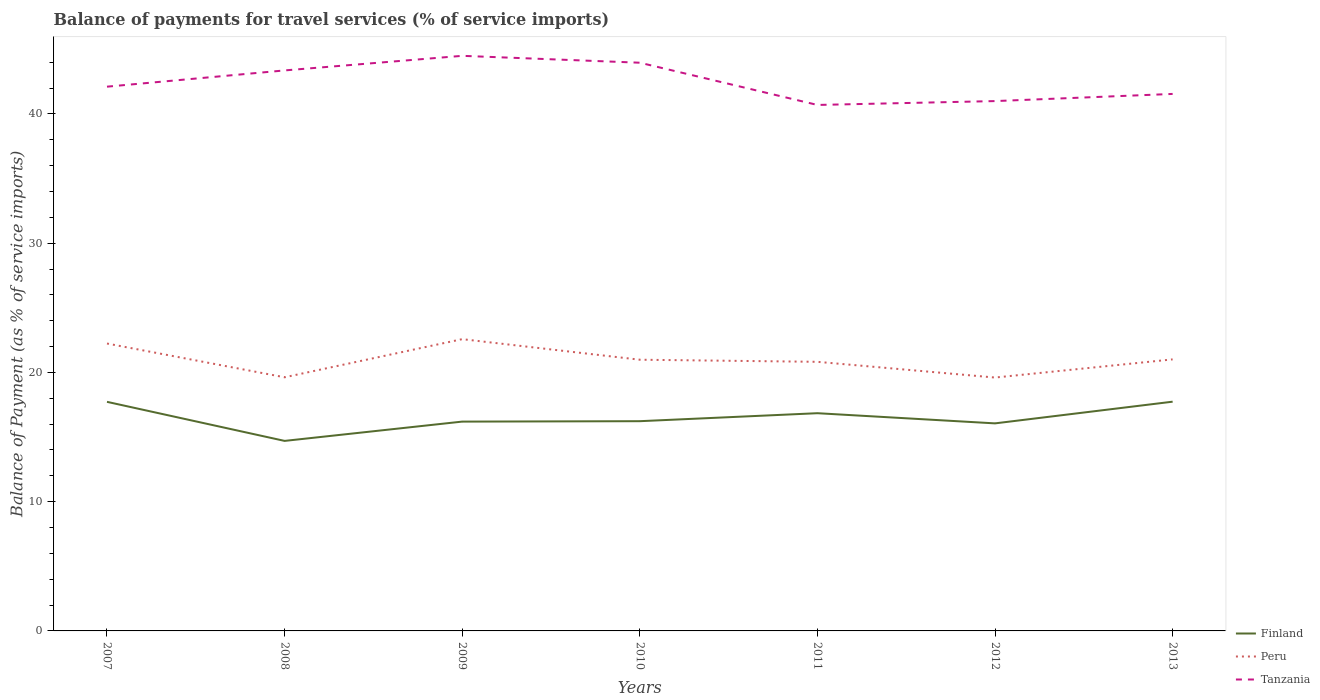Does the line corresponding to Peru intersect with the line corresponding to Tanzania?
Ensure brevity in your answer.  No. Across all years, what is the maximum balance of payments for travel services in Finland?
Ensure brevity in your answer.  14.7. In which year was the balance of payments for travel services in Tanzania maximum?
Provide a short and direct response. 2011. What is the total balance of payments for travel services in Tanzania in the graph?
Your answer should be very brief. 3.27. What is the difference between the highest and the second highest balance of payments for travel services in Tanzania?
Make the answer very short. 3.8. Is the balance of payments for travel services in Tanzania strictly greater than the balance of payments for travel services in Peru over the years?
Offer a very short reply. No. How many years are there in the graph?
Make the answer very short. 7. What is the difference between two consecutive major ticks on the Y-axis?
Ensure brevity in your answer.  10. Are the values on the major ticks of Y-axis written in scientific E-notation?
Offer a terse response. No. Where does the legend appear in the graph?
Offer a very short reply. Bottom right. How many legend labels are there?
Offer a terse response. 3. What is the title of the graph?
Give a very brief answer. Balance of payments for travel services (% of service imports). Does "New Zealand" appear as one of the legend labels in the graph?
Keep it short and to the point. No. What is the label or title of the Y-axis?
Your response must be concise. Balance of Payment (as % of service imports). What is the Balance of Payment (as % of service imports) of Finland in 2007?
Offer a very short reply. 17.73. What is the Balance of Payment (as % of service imports) of Peru in 2007?
Give a very brief answer. 22.24. What is the Balance of Payment (as % of service imports) in Tanzania in 2007?
Provide a short and direct response. 42.11. What is the Balance of Payment (as % of service imports) in Finland in 2008?
Provide a succinct answer. 14.7. What is the Balance of Payment (as % of service imports) of Peru in 2008?
Provide a short and direct response. 19.62. What is the Balance of Payment (as % of service imports) of Tanzania in 2008?
Your answer should be compact. 43.37. What is the Balance of Payment (as % of service imports) of Finland in 2009?
Provide a short and direct response. 16.2. What is the Balance of Payment (as % of service imports) in Peru in 2009?
Offer a very short reply. 22.58. What is the Balance of Payment (as % of service imports) of Tanzania in 2009?
Make the answer very short. 44.5. What is the Balance of Payment (as % of service imports) in Finland in 2010?
Your response must be concise. 16.23. What is the Balance of Payment (as % of service imports) in Peru in 2010?
Ensure brevity in your answer.  20.98. What is the Balance of Payment (as % of service imports) in Tanzania in 2010?
Your answer should be compact. 43.96. What is the Balance of Payment (as % of service imports) of Finland in 2011?
Provide a succinct answer. 16.85. What is the Balance of Payment (as % of service imports) of Peru in 2011?
Keep it short and to the point. 20.82. What is the Balance of Payment (as % of service imports) in Tanzania in 2011?
Give a very brief answer. 40.7. What is the Balance of Payment (as % of service imports) in Finland in 2012?
Your answer should be compact. 16.06. What is the Balance of Payment (as % of service imports) of Peru in 2012?
Offer a terse response. 19.6. What is the Balance of Payment (as % of service imports) of Tanzania in 2012?
Offer a very short reply. 40.99. What is the Balance of Payment (as % of service imports) of Finland in 2013?
Make the answer very short. 17.74. What is the Balance of Payment (as % of service imports) in Peru in 2013?
Your answer should be very brief. 21.01. What is the Balance of Payment (as % of service imports) of Tanzania in 2013?
Provide a short and direct response. 41.55. Across all years, what is the maximum Balance of Payment (as % of service imports) of Finland?
Make the answer very short. 17.74. Across all years, what is the maximum Balance of Payment (as % of service imports) of Peru?
Provide a succinct answer. 22.58. Across all years, what is the maximum Balance of Payment (as % of service imports) in Tanzania?
Your response must be concise. 44.5. Across all years, what is the minimum Balance of Payment (as % of service imports) in Finland?
Give a very brief answer. 14.7. Across all years, what is the minimum Balance of Payment (as % of service imports) in Peru?
Provide a short and direct response. 19.6. Across all years, what is the minimum Balance of Payment (as % of service imports) in Tanzania?
Provide a succinct answer. 40.7. What is the total Balance of Payment (as % of service imports) of Finland in the graph?
Provide a short and direct response. 115.49. What is the total Balance of Payment (as % of service imports) of Peru in the graph?
Keep it short and to the point. 146.85. What is the total Balance of Payment (as % of service imports) of Tanzania in the graph?
Keep it short and to the point. 297.18. What is the difference between the Balance of Payment (as % of service imports) in Finland in 2007 and that in 2008?
Your answer should be compact. 3.02. What is the difference between the Balance of Payment (as % of service imports) of Peru in 2007 and that in 2008?
Your response must be concise. 2.61. What is the difference between the Balance of Payment (as % of service imports) in Tanzania in 2007 and that in 2008?
Offer a very short reply. -1.26. What is the difference between the Balance of Payment (as % of service imports) in Finland in 2007 and that in 2009?
Make the answer very short. 1.53. What is the difference between the Balance of Payment (as % of service imports) in Peru in 2007 and that in 2009?
Give a very brief answer. -0.34. What is the difference between the Balance of Payment (as % of service imports) of Tanzania in 2007 and that in 2009?
Provide a succinct answer. -2.39. What is the difference between the Balance of Payment (as % of service imports) in Finland in 2007 and that in 2010?
Ensure brevity in your answer.  1.5. What is the difference between the Balance of Payment (as % of service imports) of Peru in 2007 and that in 2010?
Offer a very short reply. 1.25. What is the difference between the Balance of Payment (as % of service imports) of Tanzania in 2007 and that in 2010?
Offer a very short reply. -1.85. What is the difference between the Balance of Payment (as % of service imports) of Peru in 2007 and that in 2011?
Provide a short and direct response. 1.42. What is the difference between the Balance of Payment (as % of service imports) in Tanzania in 2007 and that in 2011?
Your answer should be very brief. 1.41. What is the difference between the Balance of Payment (as % of service imports) in Finland in 2007 and that in 2012?
Provide a succinct answer. 1.67. What is the difference between the Balance of Payment (as % of service imports) in Peru in 2007 and that in 2012?
Your answer should be very brief. 2.63. What is the difference between the Balance of Payment (as % of service imports) in Tanzania in 2007 and that in 2012?
Your response must be concise. 1.11. What is the difference between the Balance of Payment (as % of service imports) in Finland in 2007 and that in 2013?
Make the answer very short. -0.01. What is the difference between the Balance of Payment (as % of service imports) of Peru in 2007 and that in 2013?
Provide a succinct answer. 1.23. What is the difference between the Balance of Payment (as % of service imports) of Tanzania in 2007 and that in 2013?
Provide a succinct answer. 0.56. What is the difference between the Balance of Payment (as % of service imports) of Finland in 2008 and that in 2009?
Your answer should be very brief. -1.49. What is the difference between the Balance of Payment (as % of service imports) in Peru in 2008 and that in 2009?
Provide a succinct answer. -2.95. What is the difference between the Balance of Payment (as % of service imports) in Tanzania in 2008 and that in 2009?
Provide a short and direct response. -1.13. What is the difference between the Balance of Payment (as % of service imports) in Finland in 2008 and that in 2010?
Provide a short and direct response. -1.53. What is the difference between the Balance of Payment (as % of service imports) in Peru in 2008 and that in 2010?
Provide a succinct answer. -1.36. What is the difference between the Balance of Payment (as % of service imports) in Tanzania in 2008 and that in 2010?
Offer a terse response. -0.6. What is the difference between the Balance of Payment (as % of service imports) of Finland in 2008 and that in 2011?
Your answer should be compact. -2.14. What is the difference between the Balance of Payment (as % of service imports) of Peru in 2008 and that in 2011?
Provide a short and direct response. -1.2. What is the difference between the Balance of Payment (as % of service imports) of Tanzania in 2008 and that in 2011?
Make the answer very short. 2.67. What is the difference between the Balance of Payment (as % of service imports) of Finland in 2008 and that in 2012?
Offer a terse response. -1.36. What is the difference between the Balance of Payment (as % of service imports) in Peru in 2008 and that in 2012?
Give a very brief answer. 0.02. What is the difference between the Balance of Payment (as % of service imports) of Tanzania in 2008 and that in 2012?
Provide a succinct answer. 2.37. What is the difference between the Balance of Payment (as % of service imports) in Finland in 2008 and that in 2013?
Provide a succinct answer. -3.03. What is the difference between the Balance of Payment (as % of service imports) in Peru in 2008 and that in 2013?
Ensure brevity in your answer.  -1.39. What is the difference between the Balance of Payment (as % of service imports) in Tanzania in 2008 and that in 2013?
Your response must be concise. 1.82. What is the difference between the Balance of Payment (as % of service imports) in Finland in 2009 and that in 2010?
Offer a terse response. -0.03. What is the difference between the Balance of Payment (as % of service imports) of Peru in 2009 and that in 2010?
Ensure brevity in your answer.  1.59. What is the difference between the Balance of Payment (as % of service imports) of Tanzania in 2009 and that in 2010?
Make the answer very short. 0.53. What is the difference between the Balance of Payment (as % of service imports) in Finland in 2009 and that in 2011?
Offer a very short reply. -0.65. What is the difference between the Balance of Payment (as % of service imports) of Peru in 2009 and that in 2011?
Keep it short and to the point. 1.75. What is the difference between the Balance of Payment (as % of service imports) of Tanzania in 2009 and that in 2011?
Give a very brief answer. 3.8. What is the difference between the Balance of Payment (as % of service imports) in Finland in 2009 and that in 2012?
Your answer should be compact. 0.14. What is the difference between the Balance of Payment (as % of service imports) in Peru in 2009 and that in 2012?
Your answer should be compact. 2.97. What is the difference between the Balance of Payment (as % of service imports) in Tanzania in 2009 and that in 2012?
Offer a very short reply. 3.5. What is the difference between the Balance of Payment (as % of service imports) of Finland in 2009 and that in 2013?
Ensure brevity in your answer.  -1.54. What is the difference between the Balance of Payment (as % of service imports) of Peru in 2009 and that in 2013?
Provide a succinct answer. 1.57. What is the difference between the Balance of Payment (as % of service imports) of Tanzania in 2009 and that in 2013?
Ensure brevity in your answer.  2.95. What is the difference between the Balance of Payment (as % of service imports) of Finland in 2010 and that in 2011?
Make the answer very short. -0.62. What is the difference between the Balance of Payment (as % of service imports) in Peru in 2010 and that in 2011?
Make the answer very short. 0.16. What is the difference between the Balance of Payment (as % of service imports) of Tanzania in 2010 and that in 2011?
Your answer should be very brief. 3.27. What is the difference between the Balance of Payment (as % of service imports) in Finland in 2010 and that in 2012?
Ensure brevity in your answer.  0.17. What is the difference between the Balance of Payment (as % of service imports) of Peru in 2010 and that in 2012?
Offer a terse response. 1.38. What is the difference between the Balance of Payment (as % of service imports) in Tanzania in 2010 and that in 2012?
Ensure brevity in your answer.  2.97. What is the difference between the Balance of Payment (as % of service imports) of Finland in 2010 and that in 2013?
Your answer should be compact. -1.51. What is the difference between the Balance of Payment (as % of service imports) of Peru in 2010 and that in 2013?
Your answer should be very brief. -0.03. What is the difference between the Balance of Payment (as % of service imports) of Tanzania in 2010 and that in 2013?
Keep it short and to the point. 2.42. What is the difference between the Balance of Payment (as % of service imports) in Finland in 2011 and that in 2012?
Keep it short and to the point. 0.79. What is the difference between the Balance of Payment (as % of service imports) of Peru in 2011 and that in 2012?
Ensure brevity in your answer.  1.22. What is the difference between the Balance of Payment (as % of service imports) of Tanzania in 2011 and that in 2012?
Your answer should be compact. -0.3. What is the difference between the Balance of Payment (as % of service imports) of Finland in 2011 and that in 2013?
Your answer should be very brief. -0.89. What is the difference between the Balance of Payment (as % of service imports) in Peru in 2011 and that in 2013?
Give a very brief answer. -0.19. What is the difference between the Balance of Payment (as % of service imports) in Tanzania in 2011 and that in 2013?
Keep it short and to the point. -0.85. What is the difference between the Balance of Payment (as % of service imports) of Finland in 2012 and that in 2013?
Make the answer very short. -1.68. What is the difference between the Balance of Payment (as % of service imports) of Peru in 2012 and that in 2013?
Give a very brief answer. -1.41. What is the difference between the Balance of Payment (as % of service imports) in Tanzania in 2012 and that in 2013?
Provide a succinct answer. -0.55. What is the difference between the Balance of Payment (as % of service imports) in Finland in 2007 and the Balance of Payment (as % of service imports) in Peru in 2008?
Offer a very short reply. -1.9. What is the difference between the Balance of Payment (as % of service imports) of Finland in 2007 and the Balance of Payment (as % of service imports) of Tanzania in 2008?
Provide a succinct answer. -25.64. What is the difference between the Balance of Payment (as % of service imports) in Peru in 2007 and the Balance of Payment (as % of service imports) in Tanzania in 2008?
Keep it short and to the point. -21.13. What is the difference between the Balance of Payment (as % of service imports) in Finland in 2007 and the Balance of Payment (as % of service imports) in Peru in 2009?
Offer a very short reply. -4.85. What is the difference between the Balance of Payment (as % of service imports) of Finland in 2007 and the Balance of Payment (as % of service imports) of Tanzania in 2009?
Ensure brevity in your answer.  -26.77. What is the difference between the Balance of Payment (as % of service imports) in Peru in 2007 and the Balance of Payment (as % of service imports) in Tanzania in 2009?
Make the answer very short. -22.26. What is the difference between the Balance of Payment (as % of service imports) in Finland in 2007 and the Balance of Payment (as % of service imports) in Peru in 2010?
Provide a succinct answer. -3.26. What is the difference between the Balance of Payment (as % of service imports) of Finland in 2007 and the Balance of Payment (as % of service imports) of Tanzania in 2010?
Make the answer very short. -26.24. What is the difference between the Balance of Payment (as % of service imports) of Peru in 2007 and the Balance of Payment (as % of service imports) of Tanzania in 2010?
Provide a succinct answer. -21.73. What is the difference between the Balance of Payment (as % of service imports) in Finland in 2007 and the Balance of Payment (as % of service imports) in Peru in 2011?
Make the answer very short. -3.1. What is the difference between the Balance of Payment (as % of service imports) in Finland in 2007 and the Balance of Payment (as % of service imports) in Tanzania in 2011?
Offer a very short reply. -22.97. What is the difference between the Balance of Payment (as % of service imports) of Peru in 2007 and the Balance of Payment (as % of service imports) of Tanzania in 2011?
Your answer should be very brief. -18.46. What is the difference between the Balance of Payment (as % of service imports) of Finland in 2007 and the Balance of Payment (as % of service imports) of Peru in 2012?
Ensure brevity in your answer.  -1.88. What is the difference between the Balance of Payment (as % of service imports) in Finland in 2007 and the Balance of Payment (as % of service imports) in Tanzania in 2012?
Give a very brief answer. -23.27. What is the difference between the Balance of Payment (as % of service imports) of Peru in 2007 and the Balance of Payment (as % of service imports) of Tanzania in 2012?
Ensure brevity in your answer.  -18.76. What is the difference between the Balance of Payment (as % of service imports) in Finland in 2007 and the Balance of Payment (as % of service imports) in Peru in 2013?
Provide a short and direct response. -3.28. What is the difference between the Balance of Payment (as % of service imports) of Finland in 2007 and the Balance of Payment (as % of service imports) of Tanzania in 2013?
Your answer should be very brief. -23.82. What is the difference between the Balance of Payment (as % of service imports) in Peru in 2007 and the Balance of Payment (as % of service imports) in Tanzania in 2013?
Provide a short and direct response. -19.31. What is the difference between the Balance of Payment (as % of service imports) in Finland in 2008 and the Balance of Payment (as % of service imports) in Peru in 2009?
Offer a very short reply. -7.87. What is the difference between the Balance of Payment (as % of service imports) in Finland in 2008 and the Balance of Payment (as % of service imports) in Tanzania in 2009?
Offer a very short reply. -29.79. What is the difference between the Balance of Payment (as % of service imports) of Peru in 2008 and the Balance of Payment (as % of service imports) of Tanzania in 2009?
Keep it short and to the point. -24.87. What is the difference between the Balance of Payment (as % of service imports) of Finland in 2008 and the Balance of Payment (as % of service imports) of Peru in 2010?
Keep it short and to the point. -6.28. What is the difference between the Balance of Payment (as % of service imports) of Finland in 2008 and the Balance of Payment (as % of service imports) of Tanzania in 2010?
Your answer should be very brief. -29.26. What is the difference between the Balance of Payment (as % of service imports) in Peru in 2008 and the Balance of Payment (as % of service imports) in Tanzania in 2010?
Your answer should be compact. -24.34. What is the difference between the Balance of Payment (as % of service imports) of Finland in 2008 and the Balance of Payment (as % of service imports) of Peru in 2011?
Provide a short and direct response. -6.12. What is the difference between the Balance of Payment (as % of service imports) in Finland in 2008 and the Balance of Payment (as % of service imports) in Tanzania in 2011?
Keep it short and to the point. -25.99. What is the difference between the Balance of Payment (as % of service imports) of Peru in 2008 and the Balance of Payment (as % of service imports) of Tanzania in 2011?
Offer a very short reply. -21.07. What is the difference between the Balance of Payment (as % of service imports) in Finland in 2008 and the Balance of Payment (as % of service imports) in Peru in 2012?
Make the answer very short. -4.9. What is the difference between the Balance of Payment (as % of service imports) of Finland in 2008 and the Balance of Payment (as % of service imports) of Tanzania in 2012?
Your response must be concise. -26.29. What is the difference between the Balance of Payment (as % of service imports) in Peru in 2008 and the Balance of Payment (as % of service imports) in Tanzania in 2012?
Keep it short and to the point. -21.37. What is the difference between the Balance of Payment (as % of service imports) in Finland in 2008 and the Balance of Payment (as % of service imports) in Peru in 2013?
Offer a very short reply. -6.31. What is the difference between the Balance of Payment (as % of service imports) of Finland in 2008 and the Balance of Payment (as % of service imports) of Tanzania in 2013?
Offer a very short reply. -26.85. What is the difference between the Balance of Payment (as % of service imports) of Peru in 2008 and the Balance of Payment (as % of service imports) of Tanzania in 2013?
Your answer should be very brief. -21.92. What is the difference between the Balance of Payment (as % of service imports) of Finland in 2009 and the Balance of Payment (as % of service imports) of Peru in 2010?
Make the answer very short. -4.79. What is the difference between the Balance of Payment (as % of service imports) of Finland in 2009 and the Balance of Payment (as % of service imports) of Tanzania in 2010?
Ensure brevity in your answer.  -27.77. What is the difference between the Balance of Payment (as % of service imports) of Peru in 2009 and the Balance of Payment (as % of service imports) of Tanzania in 2010?
Your response must be concise. -21.39. What is the difference between the Balance of Payment (as % of service imports) in Finland in 2009 and the Balance of Payment (as % of service imports) in Peru in 2011?
Ensure brevity in your answer.  -4.63. What is the difference between the Balance of Payment (as % of service imports) of Finland in 2009 and the Balance of Payment (as % of service imports) of Tanzania in 2011?
Your answer should be compact. -24.5. What is the difference between the Balance of Payment (as % of service imports) of Peru in 2009 and the Balance of Payment (as % of service imports) of Tanzania in 2011?
Offer a very short reply. -18.12. What is the difference between the Balance of Payment (as % of service imports) in Finland in 2009 and the Balance of Payment (as % of service imports) in Peru in 2012?
Make the answer very short. -3.41. What is the difference between the Balance of Payment (as % of service imports) of Finland in 2009 and the Balance of Payment (as % of service imports) of Tanzania in 2012?
Ensure brevity in your answer.  -24.8. What is the difference between the Balance of Payment (as % of service imports) of Peru in 2009 and the Balance of Payment (as % of service imports) of Tanzania in 2012?
Offer a terse response. -18.42. What is the difference between the Balance of Payment (as % of service imports) of Finland in 2009 and the Balance of Payment (as % of service imports) of Peru in 2013?
Give a very brief answer. -4.81. What is the difference between the Balance of Payment (as % of service imports) of Finland in 2009 and the Balance of Payment (as % of service imports) of Tanzania in 2013?
Provide a succinct answer. -25.35. What is the difference between the Balance of Payment (as % of service imports) in Peru in 2009 and the Balance of Payment (as % of service imports) in Tanzania in 2013?
Give a very brief answer. -18.97. What is the difference between the Balance of Payment (as % of service imports) in Finland in 2010 and the Balance of Payment (as % of service imports) in Peru in 2011?
Your response must be concise. -4.59. What is the difference between the Balance of Payment (as % of service imports) of Finland in 2010 and the Balance of Payment (as % of service imports) of Tanzania in 2011?
Ensure brevity in your answer.  -24.47. What is the difference between the Balance of Payment (as % of service imports) of Peru in 2010 and the Balance of Payment (as % of service imports) of Tanzania in 2011?
Provide a succinct answer. -19.71. What is the difference between the Balance of Payment (as % of service imports) of Finland in 2010 and the Balance of Payment (as % of service imports) of Peru in 2012?
Make the answer very short. -3.38. What is the difference between the Balance of Payment (as % of service imports) in Finland in 2010 and the Balance of Payment (as % of service imports) in Tanzania in 2012?
Give a very brief answer. -24.77. What is the difference between the Balance of Payment (as % of service imports) in Peru in 2010 and the Balance of Payment (as % of service imports) in Tanzania in 2012?
Your answer should be compact. -20.01. What is the difference between the Balance of Payment (as % of service imports) of Finland in 2010 and the Balance of Payment (as % of service imports) of Peru in 2013?
Keep it short and to the point. -4.78. What is the difference between the Balance of Payment (as % of service imports) in Finland in 2010 and the Balance of Payment (as % of service imports) in Tanzania in 2013?
Provide a short and direct response. -25.32. What is the difference between the Balance of Payment (as % of service imports) in Peru in 2010 and the Balance of Payment (as % of service imports) in Tanzania in 2013?
Ensure brevity in your answer.  -20.57. What is the difference between the Balance of Payment (as % of service imports) in Finland in 2011 and the Balance of Payment (as % of service imports) in Peru in 2012?
Give a very brief answer. -2.76. What is the difference between the Balance of Payment (as % of service imports) of Finland in 2011 and the Balance of Payment (as % of service imports) of Tanzania in 2012?
Keep it short and to the point. -24.15. What is the difference between the Balance of Payment (as % of service imports) of Peru in 2011 and the Balance of Payment (as % of service imports) of Tanzania in 2012?
Keep it short and to the point. -20.17. What is the difference between the Balance of Payment (as % of service imports) in Finland in 2011 and the Balance of Payment (as % of service imports) in Peru in 2013?
Make the answer very short. -4.16. What is the difference between the Balance of Payment (as % of service imports) of Finland in 2011 and the Balance of Payment (as % of service imports) of Tanzania in 2013?
Offer a terse response. -24.7. What is the difference between the Balance of Payment (as % of service imports) in Peru in 2011 and the Balance of Payment (as % of service imports) in Tanzania in 2013?
Your answer should be compact. -20.73. What is the difference between the Balance of Payment (as % of service imports) of Finland in 2012 and the Balance of Payment (as % of service imports) of Peru in 2013?
Your answer should be compact. -4.95. What is the difference between the Balance of Payment (as % of service imports) of Finland in 2012 and the Balance of Payment (as % of service imports) of Tanzania in 2013?
Keep it short and to the point. -25.49. What is the difference between the Balance of Payment (as % of service imports) in Peru in 2012 and the Balance of Payment (as % of service imports) in Tanzania in 2013?
Your response must be concise. -21.94. What is the average Balance of Payment (as % of service imports) in Finland per year?
Offer a terse response. 16.5. What is the average Balance of Payment (as % of service imports) in Peru per year?
Your response must be concise. 20.98. What is the average Balance of Payment (as % of service imports) in Tanzania per year?
Ensure brevity in your answer.  42.45. In the year 2007, what is the difference between the Balance of Payment (as % of service imports) of Finland and Balance of Payment (as % of service imports) of Peru?
Your answer should be very brief. -4.51. In the year 2007, what is the difference between the Balance of Payment (as % of service imports) of Finland and Balance of Payment (as % of service imports) of Tanzania?
Offer a terse response. -24.38. In the year 2007, what is the difference between the Balance of Payment (as % of service imports) of Peru and Balance of Payment (as % of service imports) of Tanzania?
Ensure brevity in your answer.  -19.87. In the year 2008, what is the difference between the Balance of Payment (as % of service imports) in Finland and Balance of Payment (as % of service imports) in Peru?
Your answer should be compact. -4.92. In the year 2008, what is the difference between the Balance of Payment (as % of service imports) in Finland and Balance of Payment (as % of service imports) in Tanzania?
Keep it short and to the point. -28.67. In the year 2008, what is the difference between the Balance of Payment (as % of service imports) of Peru and Balance of Payment (as % of service imports) of Tanzania?
Your response must be concise. -23.74. In the year 2009, what is the difference between the Balance of Payment (as % of service imports) of Finland and Balance of Payment (as % of service imports) of Peru?
Offer a terse response. -6.38. In the year 2009, what is the difference between the Balance of Payment (as % of service imports) in Finland and Balance of Payment (as % of service imports) in Tanzania?
Offer a very short reply. -28.3. In the year 2009, what is the difference between the Balance of Payment (as % of service imports) in Peru and Balance of Payment (as % of service imports) in Tanzania?
Your answer should be very brief. -21.92. In the year 2010, what is the difference between the Balance of Payment (as % of service imports) in Finland and Balance of Payment (as % of service imports) in Peru?
Ensure brevity in your answer.  -4.76. In the year 2010, what is the difference between the Balance of Payment (as % of service imports) of Finland and Balance of Payment (as % of service imports) of Tanzania?
Your answer should be compact. -27.74. In the year 2010, what is the difference between the Balance of Payment (as % of service imports) of Peru and Balance of Payment (as % of service imports) of Tanzania?
Ensure brevity in your answer.  -22.98. In the year 2011, what is the difference between the Balance of Payment (as % of service imports) in Finland and Balance of Payment (as % of service imports) in Peru?
Your answer should be compact. -3.98. In the year 2011, what is the difference between the Balance of Payment (as % of service imports) in Finland and Balance of Payment (as % of service imports) in Tanzania?
Your answer should be very brief. -23.85. In the year 2011, what is the difference between the Balance of Payment (as % of service imports) in Peru and Balance of Payment (as % of service imports) in Tanzania?
Your answer should be very brief. -19.87. In the year 2012, what is the difference between the Balance of Payment (as % of service imports) of Finland and Balance of Payment (as % of service imports) of Peru?
Make the answer very short. -3.55. In the year 2012, what is the difference between the Balance of Payment (as % of service imports) in Finland and Balance of Payment (as % of service imports) in Tanzania?
Offer a terse response. -24.94. In the year 2012, what is the difference between the Balance of Payment (as % of service imports) of Peru and Balance of Payment (as % of service imports) of Tanzania?
Offer a very short reply. -21.39. In the year 2013, what is the difference between the Balance of Payment (as % of service imports) in Finland and Balance of Payment (as % of service imports) in Peru?
Keep it short and to the point. -3.27. In the year 2013, what is the difference between the Balance of Payment (as % of service imports) in Finland and Balance of Payment (as % of service imports) in Tanzania?
Give a very brief answer. -23.81. In the year 2013, what is the difference between the Balance of Payment (as % of service imports) of Peru and Balance of Payment (as % of service imports) of Tanzania?
Keep it short and to the point. -20.54. What is the ratio of the Balance of Payment (as % of service imports) of Finland in 2007 to that in 2008?
Make the answer very short. 1.21. What is the ratio of the Balance of Payment (as % of service imports) in Peru in 2007 to that in 2008?
Offer a terse response. 1.13. What is the ratio of the Balance of Payment (as % of service imports) of Finland in 2007 to that in 2009?
Provide a succinct answer. 1.09. What is the ratio of the Balance of Payment (as % of service imports) of Tanzania in 2007 to that in 2009?
Provide a succinct answer. 0.95. What is the ratio of the Balance of Payment (as % of service imports) of Finland in 2007 to that in 2010?
Offer a terse response. 1.09. What is the ratio of the Balance of Payment (as % of service imports) of Peru in 2007 to that in 2010?
Offer a terse response. 1.06. What is the ratio of the Balance of Payment (as % of service imports) of Tanzania in 2007 to that in 2010?
Give a very brief answer. 0.96. What is the ratio of the Balance of Payment (as % of service imports) in Finland in 2007 to that in 2011?
Your answer should be very brief. 1.05. What is the ratio of the Balance of Payment (as % of service imports) in Peru in 2007 to that in 2011?
Offer a terse response. 1.07. What is the ratio of the Balance of Payment (as % of service imports) in Tanzania in 2007 to that in 2011?
Your response must be concise. 1.03. What is the ratio of the Balance of Payment (as % of service imports) of Finland in 2007 to that in 2012?
Ensure brevity in your answer.  1.1. What is the ratio of the Balance of Payment (as % of service imports) in Peru in 2007 to that in 2012?
Offer a terse response. 1.13. What is the ratio of the Balance of Payment (as % of service imports) of Tanzania in 2007 to that in 2012?
Offer a very short reply. 1.03. What is the ratio of the Balance of Payment (as % of service imports) of Finland in 2007 to that in 2013?
Provide a succinct answer. 1. What is the ratio of the Balance of Payment (as % of service imports) in Peru in 2007 to that in 2013?
Make the answer very short. 1.06. What is the ratio of the Balance of Payment (as % of service imports) in Tanzania in 2007 to that in 2013?
Offer a terse response. 1.01. What is the ratio of the Balance of Payment (as % of service imports) of Finland in 2008 to that in 2009?
Provide a short and direct response. 0.91. What is the ratio of the Balance of Payment (as % of service imports) of Peru in 2008 to that in 2009?
Offer a very short reply. 0.87. What is the ratio of the Balance of Payment (as % of service imports) of Tanzania in 2008 to that in 2009?
Offer a terse response. 0.97. What is the ratio of the Balance of Payment (as % of service imports) in Finland in 2008 to that in 2010?
Provide a short and direct response. 0.91. What is the ratio of the Balance of Payment (as % of service imports) of Peru in 2008 to that in 2010?
Ensure brevity in your answer.  0.94. What is the ratio of the Balance of Payment (as % of service imports) of Tanzania in 2008 to that in 2010?
Provide a short and direct response. 0.99. What is the ratio of the Balance of Payment (as % of service imports) of Finland in 2008 to that in 2011?
Provide a short and direct response. 0.87. What is the ratio of the Balance of Payment (as % of service imports) of Peru in 2008 to that in 2011?
Your response must be concise. 0.94. What is the ratio of the Balance of Payment (as % of service imports) in Tanzania in 2008 to that in 2011?
Provide a short and direct response. 1.07. What is the ratio of the Balance of Payment (as % of service imports) in Finland in 2008 to that in 2012?
Your answer should be very brief. 0.92. What is the ratio of the Balance of Payment (as % of service imports) in Tanzania in 2008 to that in 2012?
Your answer should be very brief. 1.06. What is the ratio of the Balance of Payment (as % of service imports) in Finland in 2008 to that in 2013?
Provide a succinct answer. 0.83. What is the ratio of the Balance of Payment (as % of service imports) in Peru in 2008 to that in 2013?
Provide a short and direct response. 0.93. What is the ratio of the Balance of Payment (as % of service imports) in Tanzania in 2008 to that in 2013?
Ensure brevity in your answer.  1.04. What is the ratio of the Balance of Payment (as % of service imports) in Peru in 2009 to that in 2010?
Ensure brevity in your answer.  1.08. What is the ratio of the Balance of Payment (as % of service imports) in Tanzania in 2009 to that in 2010?
Offer a very short reply. 1.01. What is the ratio of the Balance of Payment (as % of service imports) in Finland in 2009 to that in 2011?
Offer a very short reply. 0.96. What is the ratio of the Balance of Payment (as % of service imports) in Peru in 2009 to that in 2011?
Your response must be concise. 1.08. What is the ratio of the Balance of Payment (as % of service imports) in Tanzania in 2009 to that in 2011?
Your answer should be very brief. 1.09. What is the ratio of the Balance of Payment (as % of service imports) in Finland in 2009 to that in 2012?
Ensure brevity in your answer.  1.01. What is the ratio of the Balance of Payment (as % of service imports) in Peru in 2009 to that in 2012?
Provide a succinct answer. 1.15. What is the ratio of the Balance of Payment (as % of service imports) in Tanzania in 2009 to that in 2012?
Your answer should be very brief. 1.09. What is the ratio of the Balance of Payment (as % of service imports) in Finland in 2009 to that in 2013?
Make the answer very short. 0.91. What is the ratio of the Balance of Payment (as % of service imports) in Peru in 2009 to that in 2013?
Your response must be concise. 1.07. What is the ratio of the Balance of Payment (as % of service imports) in Tanzania in 2009 to that in 2013?
Ensure brevity in your answer.  1.07. What is the ratio of the Balance of Payment (as % of service imports) in Finland in 2010 to that in 2011?
Ensure brevity in your answer.  0.96. What is the ratio of the Balance of Payment (as % of service imports) in Peru in 2010 to that in 2011?
Provide a succinct answer. 1.01. What is the ratio of the Balance of Payment (as % of service imports) in Tanzania in 2010 to that in 2011?
Provide a short and direct response. 1.08. What is the ratio of the Balance of Payment (as % of service imports) in Finland in 2010 to that in 2012?
Keep it short and to the point. 1.01. What is the ratio of the Balance of Payment (as % of service imports) in Peru in 2010 to that in 2012?
Your response must be concise. 1.07. What is the ratio of the Balance of Payment (as % of service imports) of Tanzania in 2010 to that in 2012?
Ensure brevity in your answer.  1.07. What is the ratio of the Balance of Payment (as % of service imports) of Finland in 2010 to that in 2013?
Make the answer very short. 0.91. What is the ratio of the Balance of Payment (as % of service imports) of Tanzania in 2010 to that in 2013?
Offer a very short reply. 1.06. What is the ratio of the Balance of Payment (as % of service imports) in Finland in 2011 to that in 2012?
Offer a terse response. 1.05. What is the ratio of the Balance of Payment (as % of service imports) in Peru in 2011 to that in 2012?
Make the answer very short. 1.06. What is the ratio of the Balance of Payment (as % of service imports) of Finland in 2011 to that in 2013?
Offer a terse response. 0.95. What is the ratio of the Balance of Payment (as % of service imports) of Peru in 2011 to that in 2013?
Your response must be concise. 0.99. What is the ratio of the Balance of Payment (as % of service imports) of Tanzania in 2011 to that in 2013?
Offer a very short reply. 0.98. What is the ratio of the Balance of Payment (as % of service imports) in Finland in 2012 to that in 2013?
Your answer should be very brief. 0.91. What is the ratio of the Balance of Payment (as % of service imports) of Peru in 2012 to that in 2013?
Offer a terse response. 0.93. What is the ratio of the Balance of Payment (as % of service imports) of Tanzania in 2012 to that in 2013?
Offer a terse response. 0.99. What is the difference between the highest and the second highest Balance of Payment (as % of service imports) in Finland?
Keep it short and to the point. 0.01. What is the difference between the highest and the second highest Balance of Payment (as % of service imports) of Peru?
Make the answer very short. 0.34. What is the difference between the highest and the second highest Balance of Payment (as % of service imports) in Tanzania?
Provide a succinct answer. 0.53. What is the difference between the highest and the lowest Balance of Payment (as % of service imports) of Finland?
Provide a short and direct response. 3.03. What is the difference between the highest and the lowest Balance of Payment (as % of service imports) of Peru?
Provide a short and direct response. 2.97. What is the difference between the highest and the lowest Balance of Payment (as % of service imports) in Tanzania?
Ensure brevity in your answer.  3.8. 